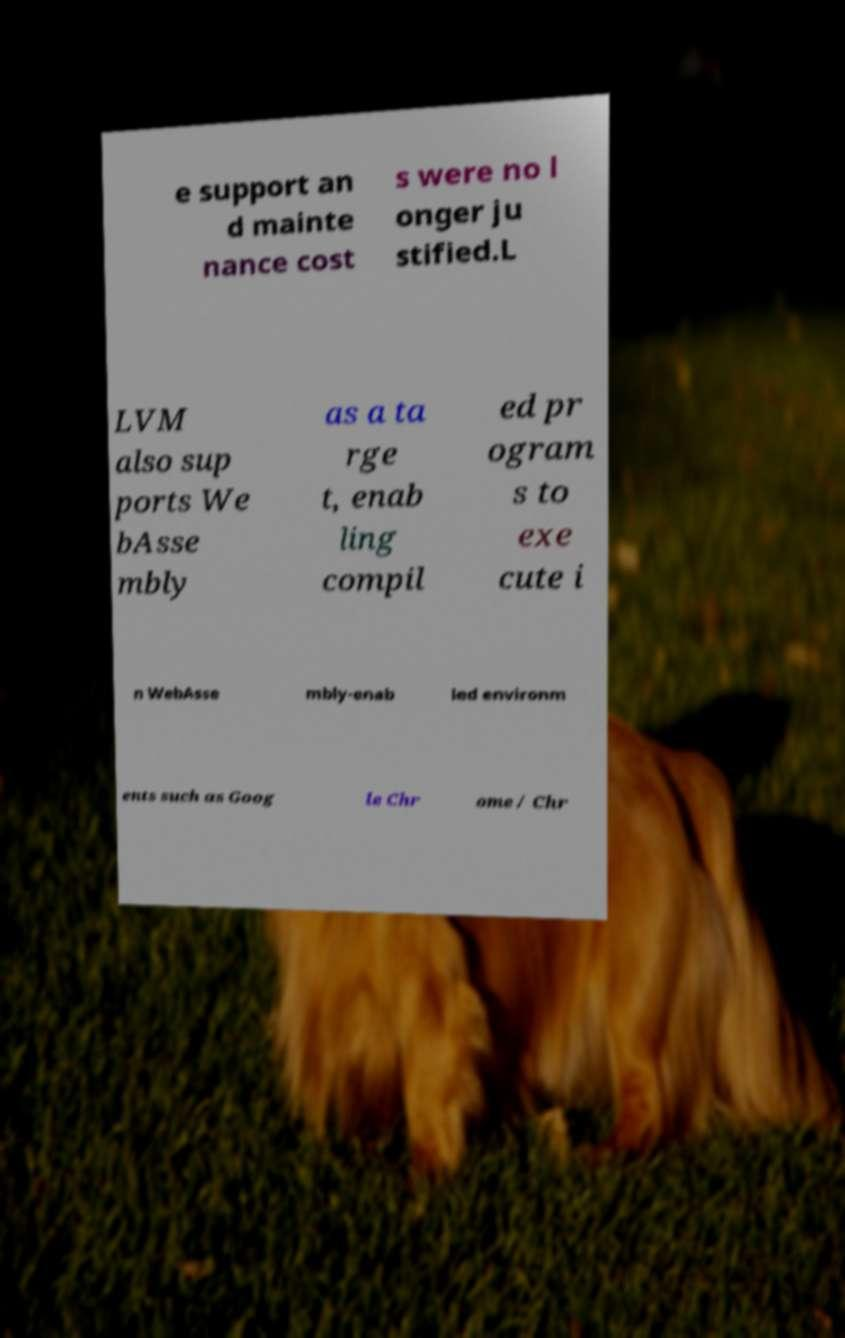Can you accurately transcribe the text from the provided image for me? e support an d mainte nance cost s were no l onger ju stified.L LVM also sup ports We bAsse mbly as a ta rge t, enab ling compil ed pr ogram s to exe cute i n WebAsse mbly-enab led environm ents such as Goog le Chr ome / Chr 